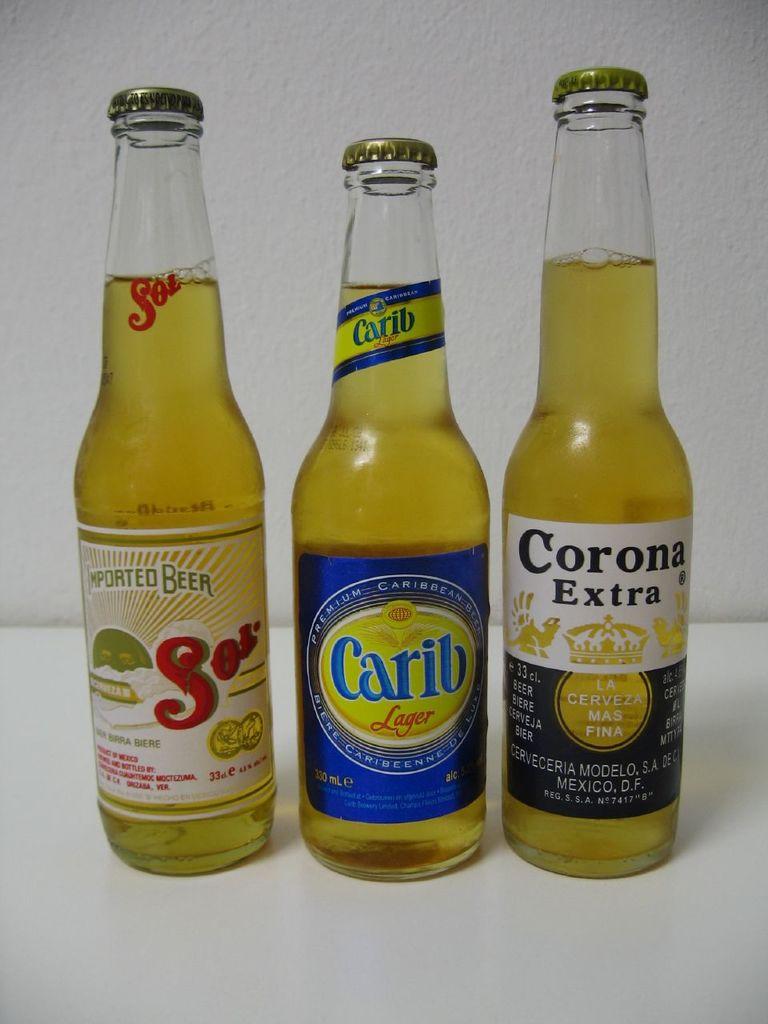What beer is on the left?
Ensure brevity in your answer.  Sol. 